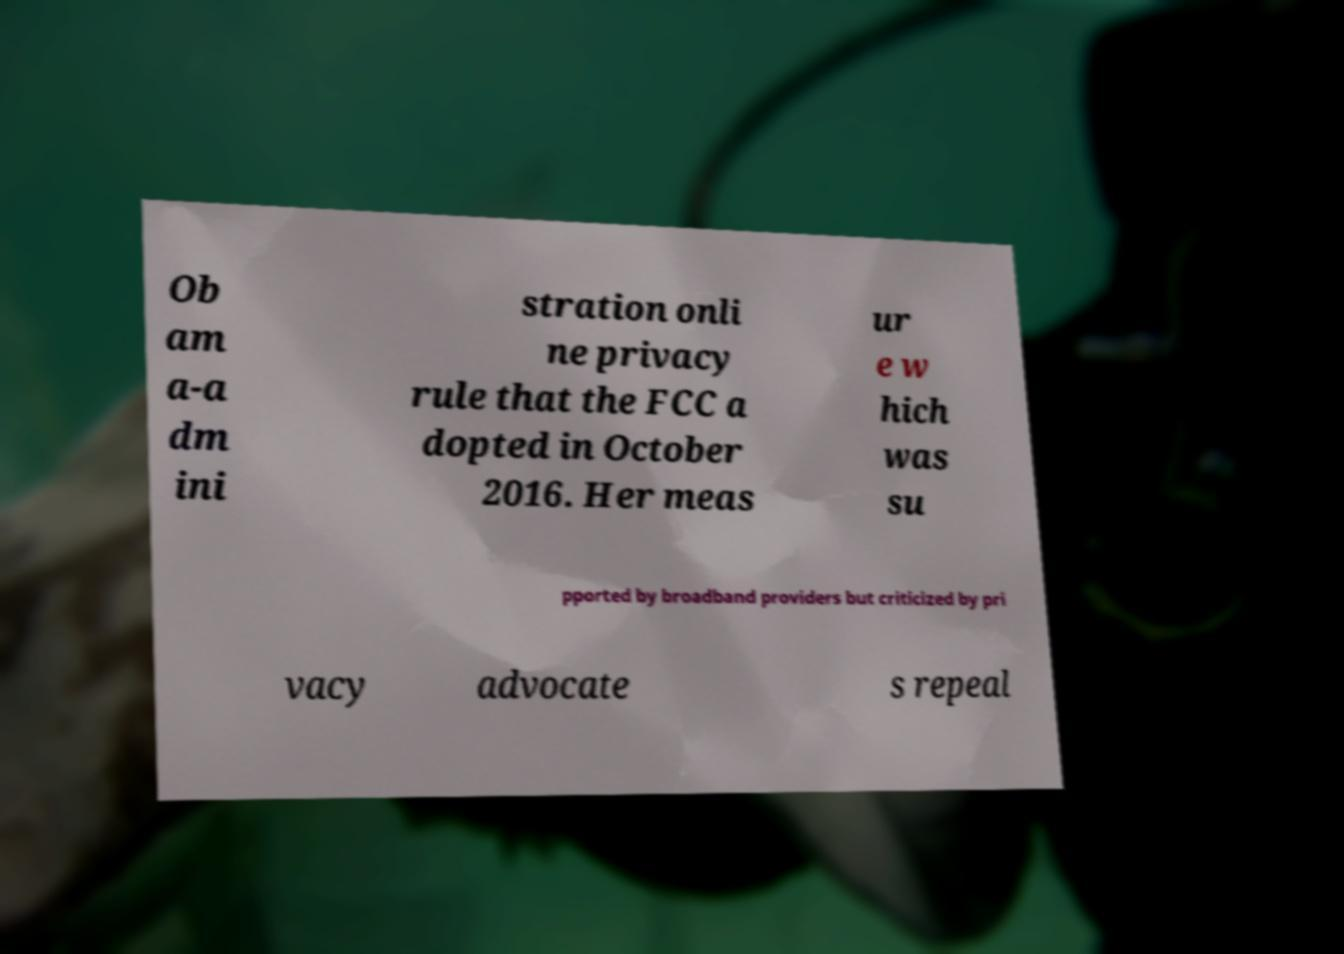Please read and relay the text visible in this image. What does it say? Ob am a-a dm ini stration onli ne privacy rule that the FCC a dopted in October 2016. Her meas ur e w hich was su pported by broadband providers but criticized by pri vacy advocate s repeal 